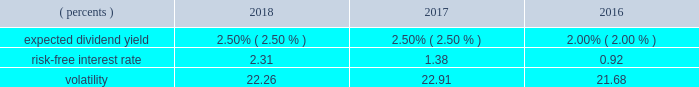Shareholder value award program svas are granted to officers and management and are payable in shares of our common stock .
The number of shares actually issued , if any , varies depending on our stock price at the end of the three-year vesting period compared to pre-established target stock prices .
We measure the fair value of the sva unit on the grant date using a monte carlo simulation model .
The model utilizes multiple input variables that determine the probability of satisfying the market condition stipulated in the award grant and calculates the fair value of the award .
Expected volatilities utilized in the model are based on implied volatilities from traded options on our stock , historical volatility of our stock price , and other factors .
Similarly , the dividend yield is based on historical experience and our estimate of future dividend yields .
The risk-free interest rate is derived from the u.s .
Treasury yield curve in effect at the time of grant .
The weighted-average fair values of the sva units granted during the years ended december 31 , 2018 , 2017 , and 2016 were $ 48.51 , $ 66.25 , and $ 48.68 , respectively , determined using the following assumptions: .
Pursuant to this program , approximately 0.7 million shares , 1.1 million shares , and 1.0 million shares were issued during the years ended december 31 , 2018 , 2017 , and 2016 , respectively .
Approximately 1.0 million shares are expected to be issued in 2019 .
As of december 31 , 2018 , the total remaining unrecognized compensation cost related to nonvested svas was $ 55.7 million , which will be amortized over the weighted-average remaining requisite service period of 20 months .
Restricted stock units rsus are granted to certain employees and are payable in shares of our common stock .
Rsu shares are accounted for at fair value based upon the closing stock price on the date of grant .
The corresponding expense is amortized over the vesting period , typically three years .
The fair values of rsu awards granted during the years ended december 31 , 2018 , 2017 , and 2016 were $ 70.95 , $ 72.47 , and $ 71.46 , respectively .
The number of shares ultimately issued for the rsu program remains constant with the exception of forfeitures .
Pursuant to this program , 1.3 million , 1.4 million , and 1.3 million shares were granted and approximately 1.0 million , 0.9 million , and 0.6 million shares were issued during the years ended december 31 , 2018 , 2017 , and 2016 , respectively .
Approximately 0.8 million shares are expected to be issued in 2019 .
As of december 31 , 2018 , the total remaining unrecognized compensation cost related to nonvested rsus was $ 112.2 million , which will be amortized over the weighted- average remaining requisite service period of 21 months .
Note 12 : shareholders' equity during 2018 , 2017 , and 2016 , we repurchased $ 4.15 billion , $ 359.8 million and $ 540.1 million , respectively , of shares associated with our share repurchase programs .
A payment of $ 60.0 million was made in 2016 for shares repurchased in 2017 .
During 2018 , we repurchased $ 2.05 billion of shares , which completed the $ 5.00 billion share repurchase program announced in october 2013 and our board authorized an $ 8.00 billion share repurchase program .
There were $ 2.10 billion repurchased under the $ 8.00 billion program in 2018 .
As of december 31 , 2018 , there were $ 5.90 billion of shares remaining under the 2018 program .
We have 5.0 million authorized shares of preferred stock .
As of december 31 , 2018 and 2017 , no preferred stock was issued .
We have an employee benefit trust that held 50.0 million shares of our common stock at both december 31 , 2018 and 2017 , to provide a source of funds to assist us in meeting our obligations under various employee benefit plans .
The cost basis of the shares held in the trust was $ 3.01 billion at both december 31 , 2018 and 2017 , and is shown as a reduction of shareholders 2019 equity .
Any dividend transactions between us and the trust are eliminated .
Stock held by the trust is not considered outstanding in the computation of eps .
The assets of the trust were not used to fund any of our obligations under these employee benefit plans during the years ended december 31 , 2018 , 2017 , and .
What was the percentage change in dollars spent on share repurchase between 2017 and 2018? 
Computations: (((4.15 * 1000) - 359.8) / 359.8)
Answer: 10.53419. 